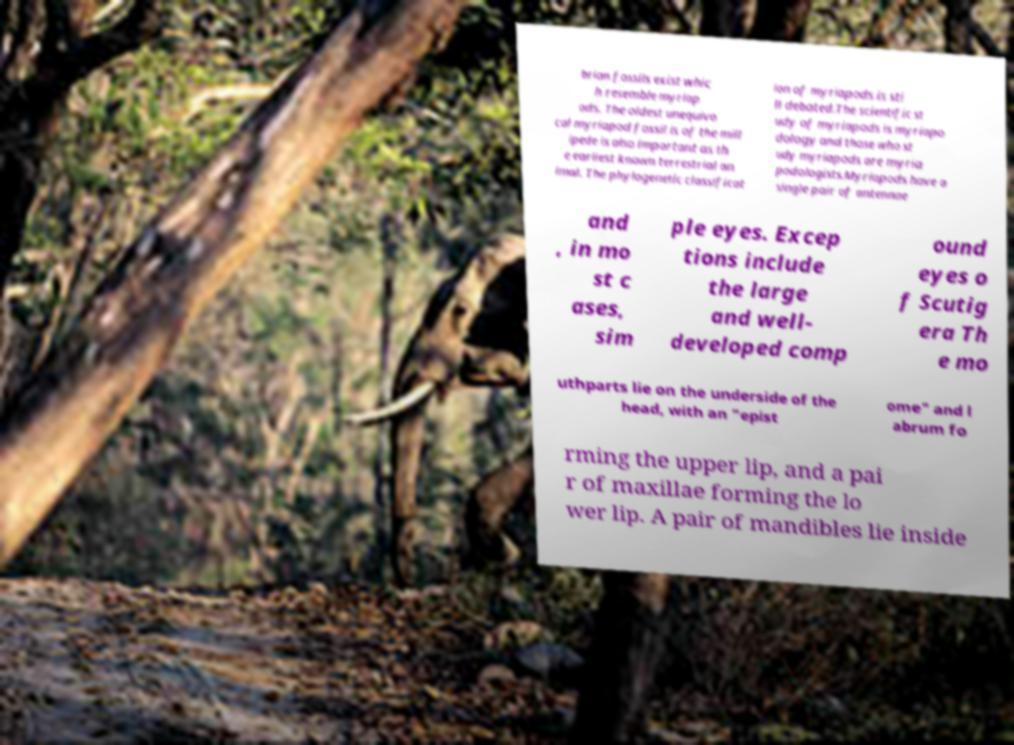Could you assist in decoding the text presented in this image and type it out clearly? brian fossils exist whic h resemble myriap ods. The oldest unequivo cal myriapod fossil is of the mill ipede is also important as th e earliest known terrestrial an imal. The phylogenetic classificat ion of myriapods is sti ll debated.The scientific st udy of myriapods is myriapo dology and those who st udy myriapods are myria podologists.Myriapods have a single pair of antennae and , in mo st c ases, sim ple eyes. Excep tions include the large and well- developed comp ound eyes o f Scutig era Th e mo uthparts lie on the underside of the head, with an "epist ome" and l abrum fo rming the upper lip, and a pai r of maxillae forming the lo wer lip. A pair of mandibles lie inside 